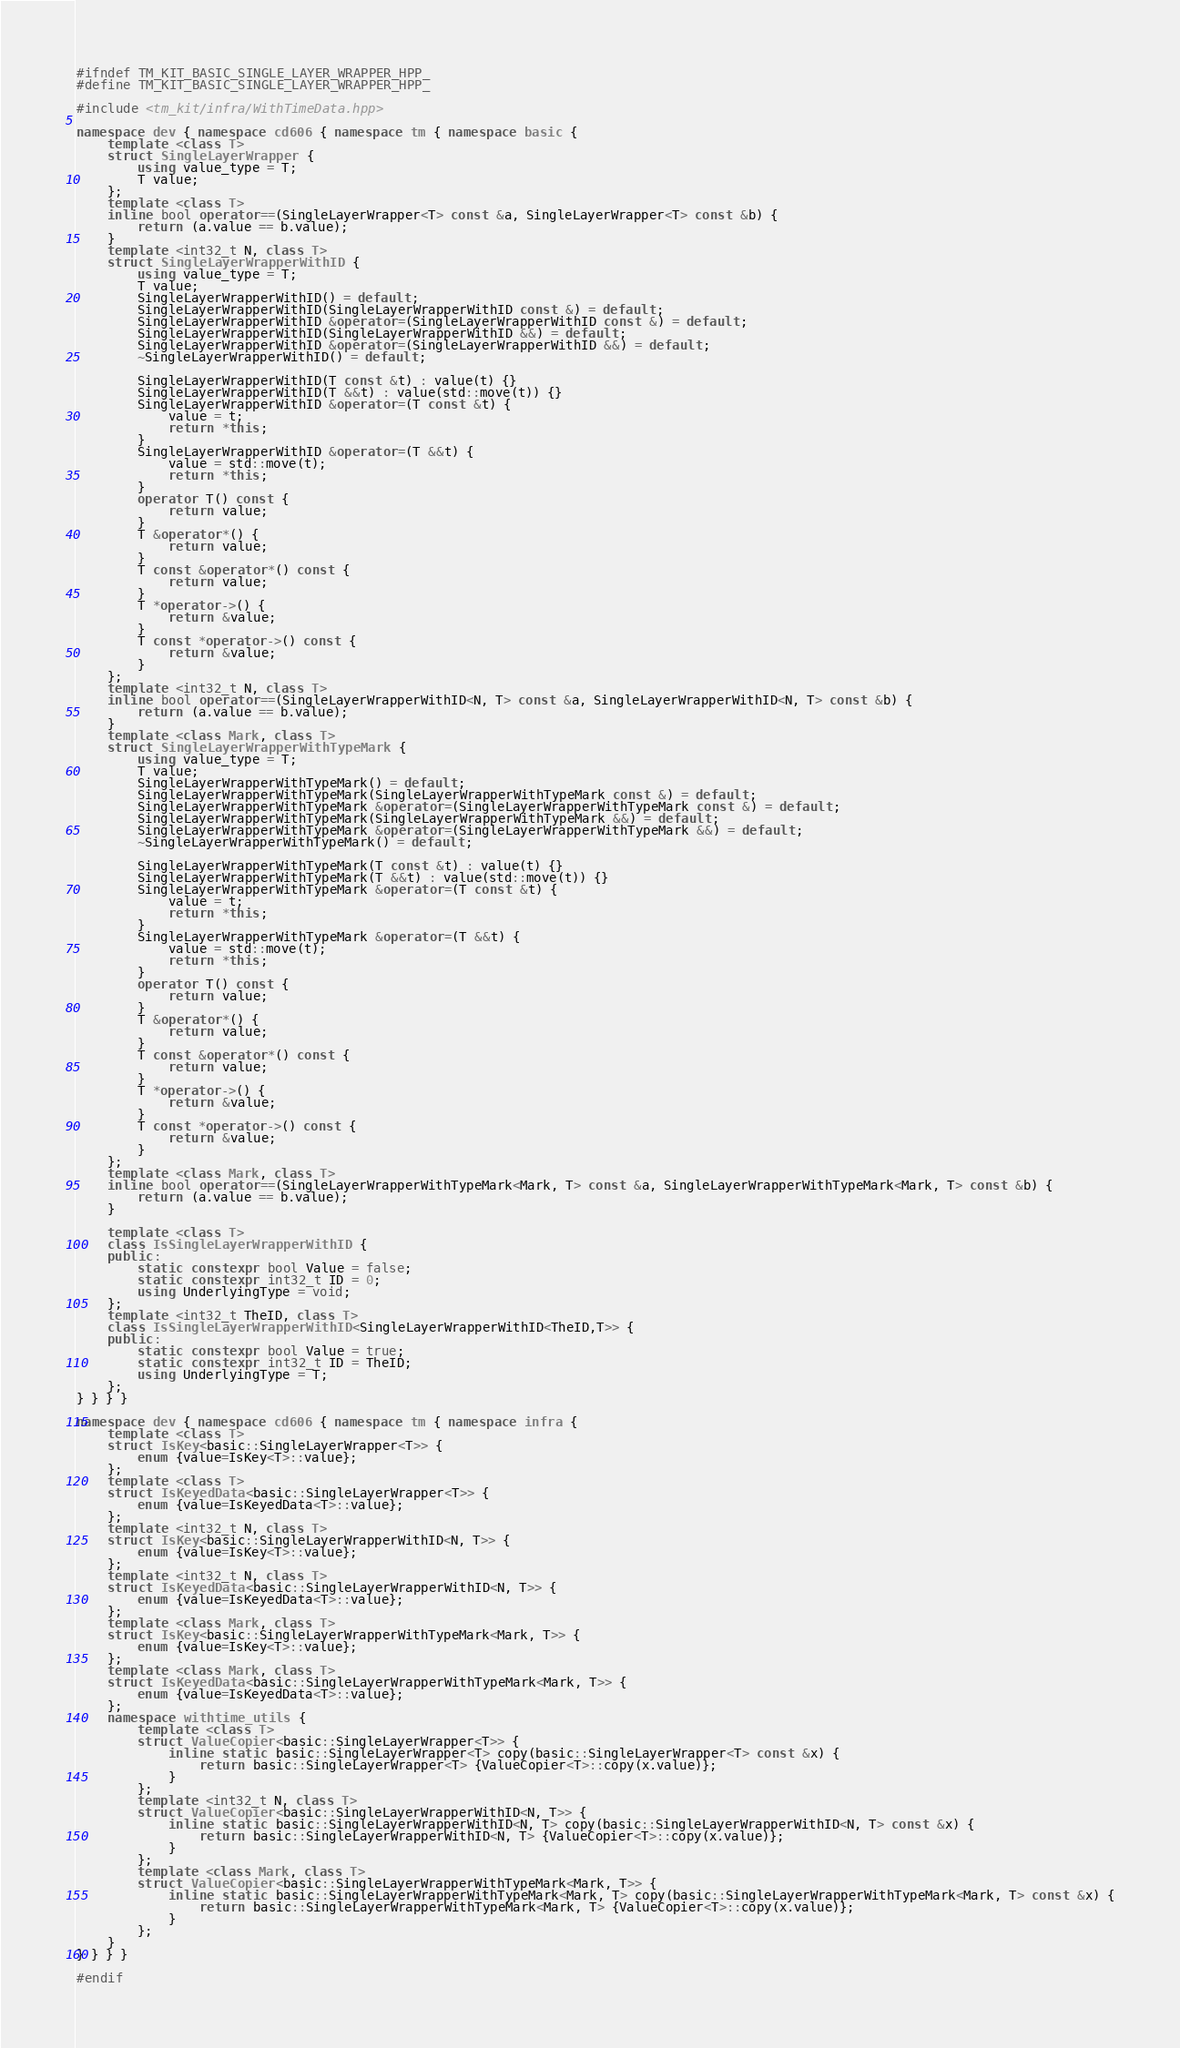Convert code to text. <code><loc_0><loc_0><loc_500><loc_500><_C++_>#ifndef TM_KIT_BASIC_SINGLE_LAYER_WRAPPER_HPP_
#define TM_KIT_BASIC_SINGLE_LAYER_WRAPPER_HPP_

#include <tm_kit/infra/WithTimeData.hpp>

namespace dev { namespace cd606 { namespace tm { namespace basic {
    template <class T>
    struct SingleLayerWrapper {
        using value_type = T;
        T value;
    };
    template <class T>
    inline bool operator==(SingleLayerWrapper<T> const &a, SingleLayerWrapper<T> const &b) {
        return (a.value == b.value);
    }
    template <int32_t N, class T>
    struct SingleLayerWrapperWithID {
        using value_type = T;
        T value;
        SingleLayerWrapperWithID() = default;
        SingleLayerWrapperWithID(SingleLayerWrapperWithID const &) = default;
        SingleLayerWrapperWithID &operator=(SingleLayerWrapperWithID const &) = default;
        SingleLayerWrapperWithID(SingleLayerWrapperWithID &&) = default;
        SingleLayerWrapperWithID &operator=(SingleLayerWrapperWithID &&) = default;
        ~SingleLayerWrapperWithID() = default;

        SingleLayerWrapperWithID(T const &t) : value(t) {}
        SingleLayerWrapperWithID(T &&t) : value(std::move(t)) {}
        SingleLayerWrapperWithID &operator=(T const &t) {
            value = t;
            return *this;
        }
        SingleLayerWrapperWithID &operator=(T &&t) {
            value = std::move(t);
            return *this;
        }
        operator T() const {
            return value;
        }
        T &operator*() {
            return value;
        }
        T const &operator*() const {
            return value;
        }
        T *operator->() {
            return &value;
        }
        T const *operator->() const {
            return &value;
        }
    };
    template <int32_t N, class T>
    inline bool operator==(SingleLayerWrapperWithID<N, T> const &a, SingleLayerWrapperWithID<N, T> const &b) {
        return (a.value == b.value);
    }
    template <class Mark, class T>
    struct SingleLayerWrapperWithTypeMark {
        using value_type = T;
        T value;
        SingleLayerWrapperWithTypeMark() = default;
        SingleLayerWrapperWithTypeMark(SingleLayerWrapperWithTypeMark const &) = default;
        SingleLayerWrapperWithTypeMark &operator=(SingleLayerWrapperWithTypeMark const &) = default;
        SingleLayerWrapperWithTypeMark(SingleLayerWrapperWithTypeMark &&) = default;
        SingleLayerWrapperWithTypeMark &operator=(SingleLayerWrapperWithTypeMark &&) = default;
        ~SingleLayerWrapperWithTypeMark() = default;

        SingleLayerWrapperWithTypeMark(T const &t) : value(t) {}
        SingleLayerWrapperWithTypeMark(T &&t) : value(std::move(t)) {}
        SingleLayerWrapperWithTypeMark &operator=(T const &t) {
            value = t;
            return *this;
        }
        SingleLayerWrapperWithTypeMark &operator=(T &&t) {
            value = std::move(t);
            return *this;
        }
        operator T() const {
            return value;
        }
        T &operator*() {
            return value;
        }
        T const &operator*() const {
            return value;
        }
        T *operator->() {
            return &value;
        }
        T const *operator->() const {
            return &value;
        }
    };
    template <class Mark, class T>
    inline bool operator==(SingleLayerWrapperWithTypeMark<Mark, T> const &a, SingleLayerWrapperWithTypeMark<Mark, T> const &b) {
        return (a.value == b.value);
    }

    template <class T>
    class IsSingleLayerWrapperWithID {
    public:
        static constexpr bool Value = false;
        static constexpr int32_t ID = 0;
        using UnderlyingType = void;
    };
    template <int32_t TheID, class T>
    class IsSingleLayerWrapperWithID<SingleLayerWrapperWithID<TheID,T>> {
    public:
        static constexpr bool Value = true;
        static constexpr int32_t ID = TheID;
        using UnderlyingType = T;
    };
} } } }

namespace dev { namespace cd606 { namespace tm { namespace infra {
    template <class T>
    struct IsKey<basic::SingleLayerWrapper<T>> {
	    enum {value=IsKey<T>::value};
    };
    template <class T>
    struct IsKeyedData<basic::SingleLayerWrapper<T>> {
	    enum {value=IsKeyedData<T>::value};
    };
    template <int32_t N, class T>
    struct IsKey<basic::SingleLayerWrapperWithID<N, T>> {
	    enum {value=IsKey<T>::value};
    };
    template <int32_t N, class T>
    struct IsKeyedData<basic::SingleLayerWrapperWithID<N, T>> {
	    enum {value=IsKeyedData<T>::value};
    };
    template <class Mark, class T>
    struct IsKey<basic::SingleLayerWrapperWithTypeMark<Mark, T>> {
	    enum {value=IsKey<T>::value};
    };
    template <class Mark, class T>
    struct IsKeyedData<basic::SingleLayerWrapperWithTypeMark<Mark, T>> {
	    enum {value=IsKeyedData<T>::value};
    };
    namespace withtime_utils {
        template <class T>
        struct ValueCopier<basic::SingleLayerWrapper<T>> {
            inline static basic::SingleLayerWrapper<T> copy(basic::SingleLayerWrapper<T> const &x) {
                return basic::SingleLayerWrapper<T> {ValueCopier<T>::copy(x.value)};
            }
        };
        template <int32_t N, class T>
        struct ValueCopier<basic::SingleLayerWrapperWithID<N, T>> {
            inline static basic::SingleLayerWrapperWithID<N, T> copy(basic::SingleLayerWrapperWithID<N, T> const &x) {
                return basic::SingleLayerWrapperWithID<N, T> {ValueCopier<T>::copy(x.value)};
            }
        };
        template <class Mark, class T>
        struct ValueCopier<basic::SingleLayerWrapperWithTypeMark<Mark, T>> {
            inline static basic::SingleLayerWrapperWithTypeMark<Mark, T> copy(basic::SingleLayerWrapperWithTypeMark<Mark, T> const &x) {
                return basic::SingleLayerWrapperWithTypeMark<Mark, T> {ValueCopier<T>::copy(x.value)};
            }
        };
    }
} } } }

#endif</code> 